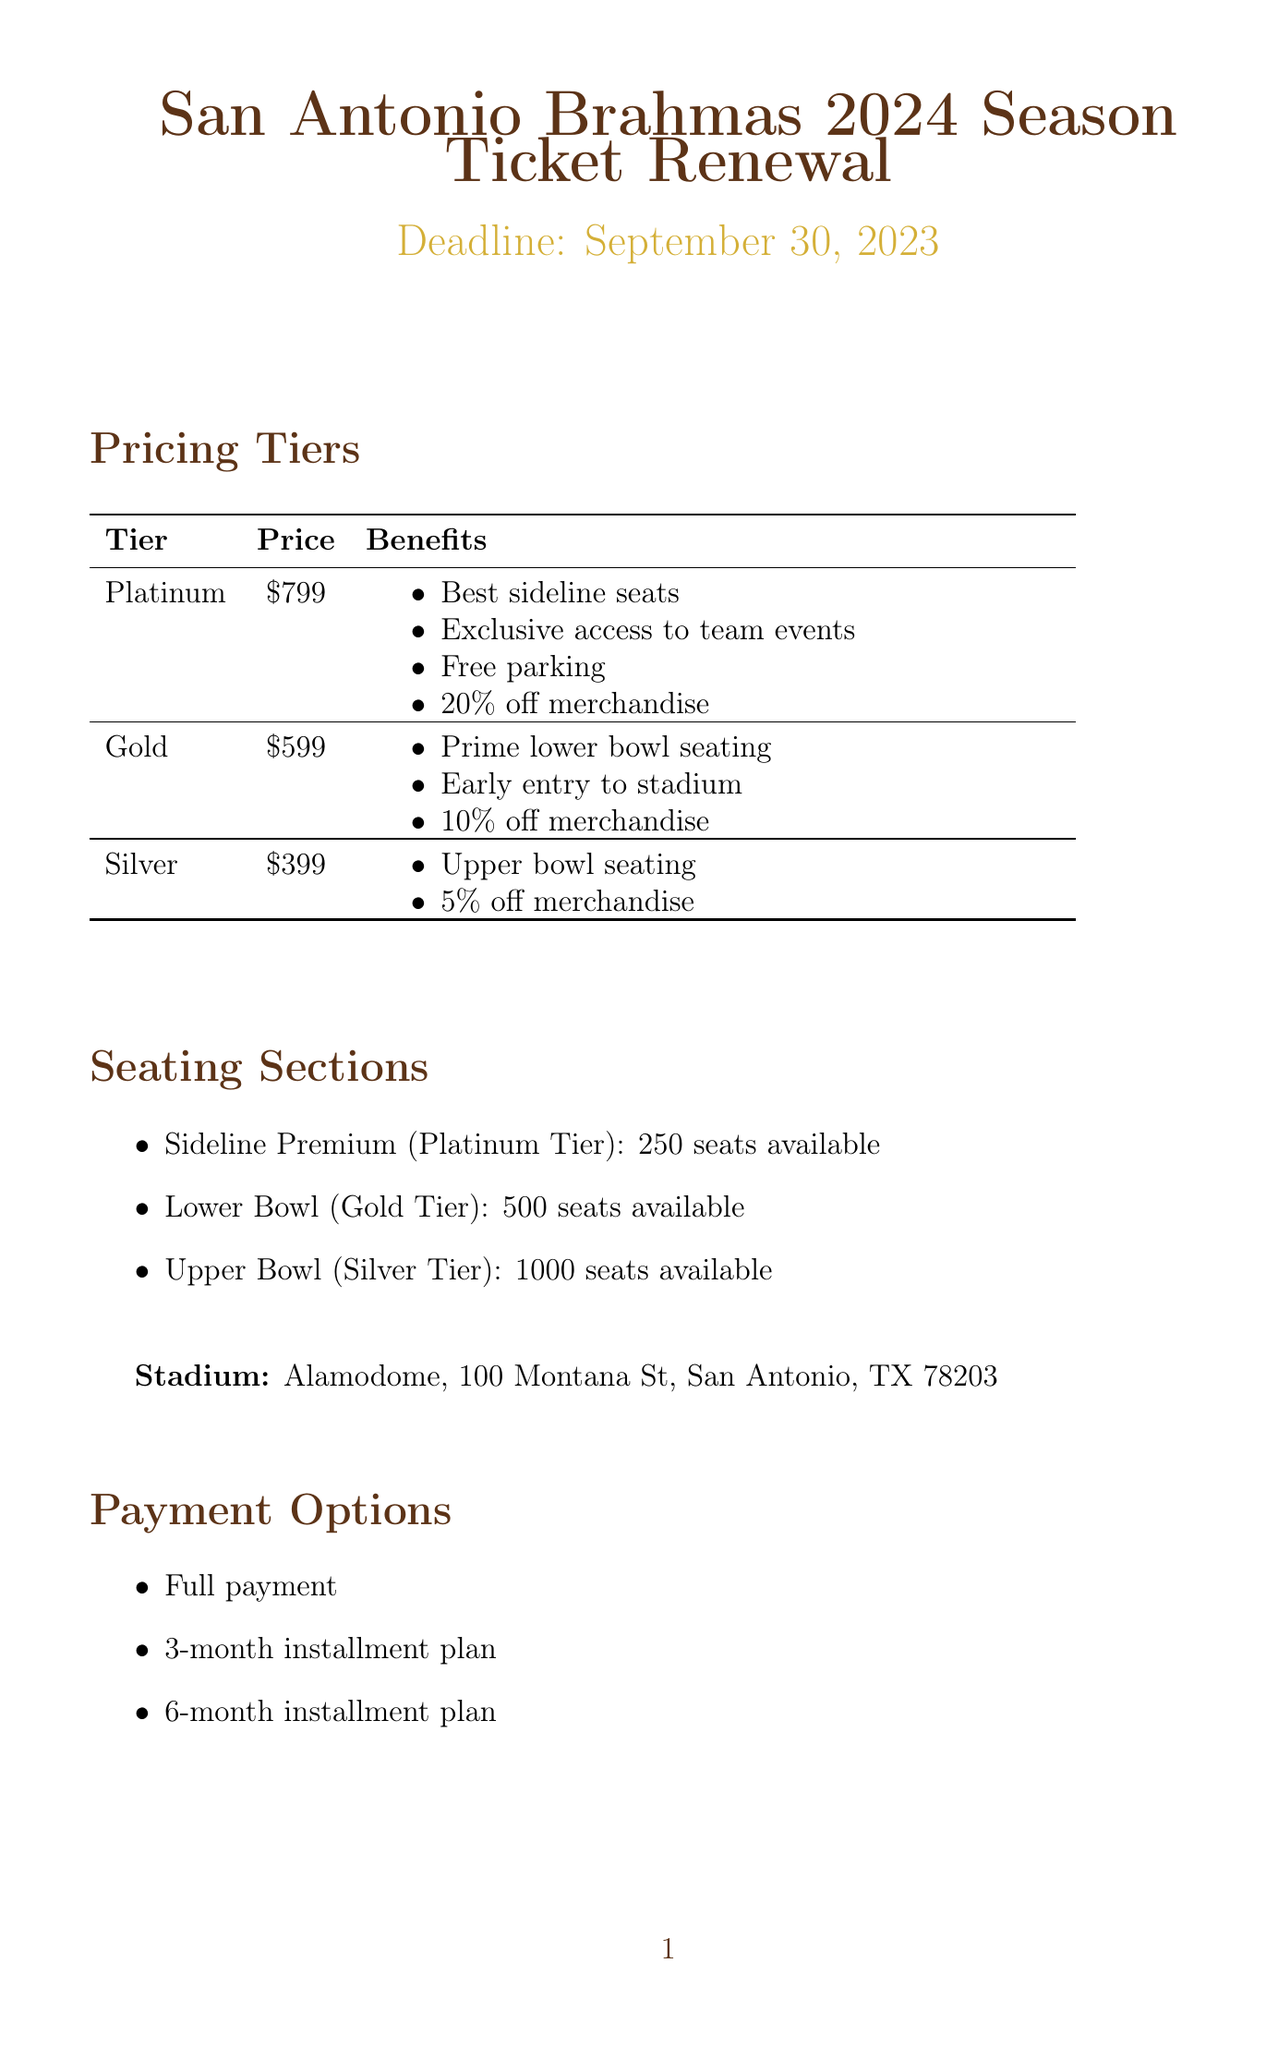what is the price of the Platinum tier? The Platinum tier is priced at $799 as stated in the pricing section.
Answer: $799 what is the deadline for season ticket renewal? The form states that the renewal deadline is September 30, 2023.
Answer: September 30, 2023 how many seats are available in the Lower Bowl? The document indicates that there are 500 available seats in the Lower Bowl section.
Answer: 500 what is the benefit of the Gold tier regarding merchandise? The Gold tier offers a 10% discount on merchandise as listed in the benefits.
Answer: 10% off merchandise what is included in the Brahmas Tailgate Package? The Tailgate Package includes access to the pre-game tailgate area with food and drinks.
Answer: Access to pre-game tailgate area with food and drinks how much is the Parking Pass? The Parking Pass is priced at $150 according to the add-ons section.
Answer: $150 what code do you use for the Early Bird Discount? The document specifies that the code for the Early Bird Discount is EARLYBIRD2024.
Answer: EARLYBIRD2024 can I transfer my tickets? The FAQ section confirms that you can transfer your tickets through the official mobile app.
Answer: Yes, through the official mobile app what is the name of the stadium? The document mentions that the name of the stadium is Alamodome.
Answer: Alamodome 